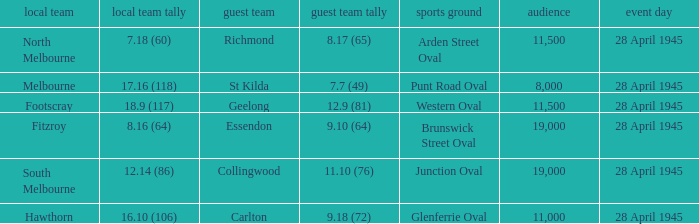Which home team has an Away team of essendon? 8.16 (64). Write the full table. {'header': ['local team', 'local team tally', 'guest team', 'guest team tally', 'sports ground', 'audience', 'event day'], 'rows': [['North Melbourne', '7.18 (60)', 'Richmond', '8.17 (65)', 'Arden Street Oval', '11,500', '28 April 1945'], ['Melbourne', '17.16 (118)', 'St Kilda', '7.7 (49)', 'Punt Road Oval', '8,000', '28 April 1945'], ['Footscray', '18.9 (117)', 'Geelong', '12.9 (81)', 'Western Oval', '11,500', '28 April 1945'], ['Fitzroy', '8.16 (64)', 'Essendon', '9.10 (64)', 'Brunswick Street Oval', '19,000', '28 April 1945'], ['South Melbourne', '12.14 (86)', 'Collingwood', '11.10 (76)', 'Junction Oval', '19,000', '28 April 1945'], ['Hawthorn', '16.10 (106)', 'Carlton', '9.18 (72)', 'Glenferrie Oval', '11,000', '28 April 1945']]} 